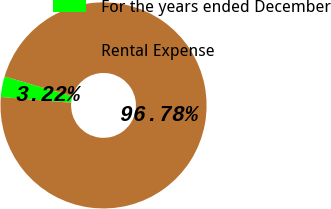Convert chart to OTSL. <chart><loc_0><loc_0><loc_500><loc_500><pie_chart><fcel>For the years ended December<fcel>Rental Expense<nl><fcel>3.22%<fcel>96.78%<nl></chart> 